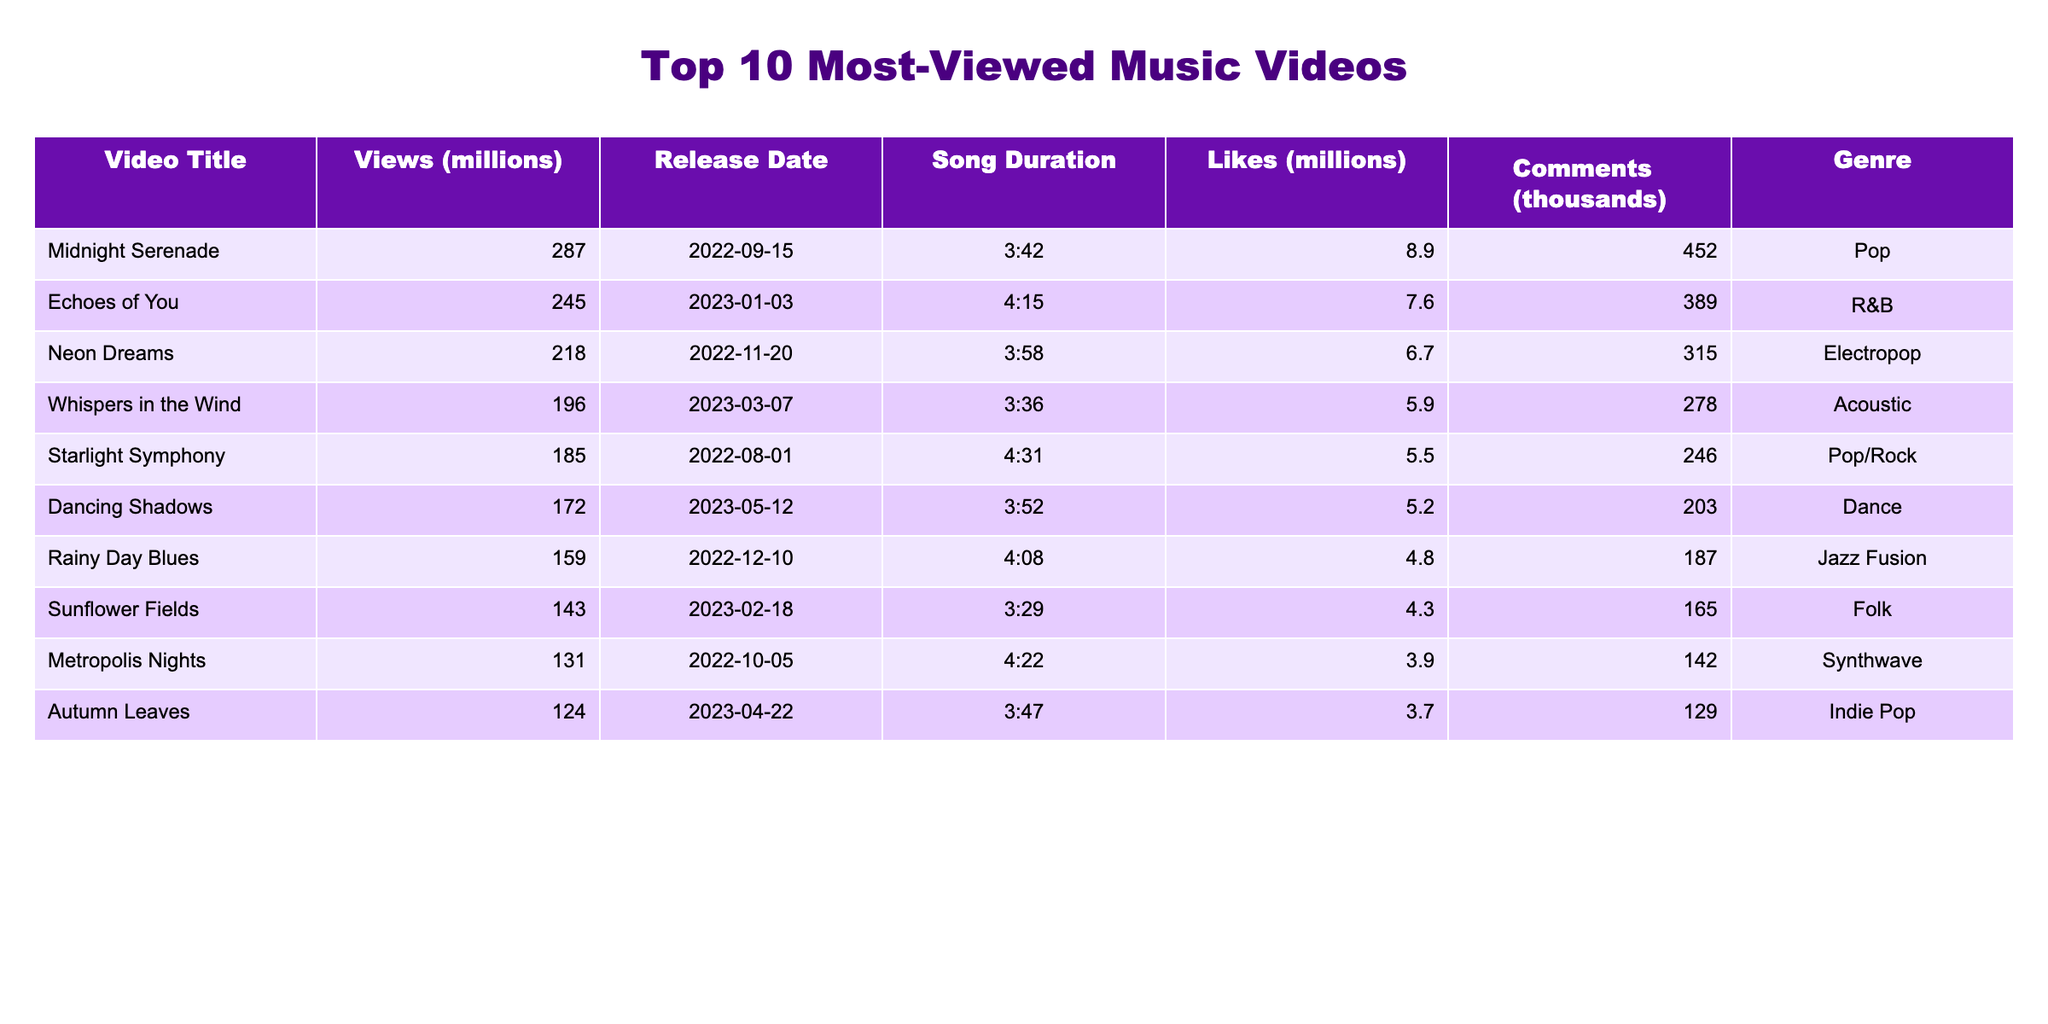What is the title of the most-viewed music video? The table indicates that "Midnight Serenade" has the highest number of views at 287 million.
Answer: Midnight Serenade How many likes did "Whispers in the Wind" receive? The table shows that "Whispers in the Wind" received 5.9 million likes.
Answer: 5.9 million What is the release date of "Neon Dreams"? The release date listed for "Neon Dreams" is November 20, 2022.
Answer: November 20, 2022 Which music video has the least number of views? According to the table, "Autumn Leaves" has the least views at 124 million.
Answer: Autumn Leaves What is the total number of views for the top 3 music videos? The views for the top 3 music videos are 287 million, 245 million, and 218 million. The total is 287 + 245 + 218 = 750 million.
Answer: 750 million What genre does "Dancing Shadows" belong to? The table categorizes "Dancing Shadows" under the Dance genre.
Answer: Dance Is "Starlight Symphony" more popular than "Rainy Day Blues" in terms of views? "Starlight Symphony" has 185 million views while "Rainy Day Blues" has 159 million views. Therefore, "Starlight Symphony" is indeed more popular.
Answer: Yes What is the average number of comments for all music videos listed? The total number of comments is 452 + 389 + 315 + 278 + 246 + 203 + 187 + 165 + 142 + 129 = 2,831 thousand. Dividing by 10 gives an average of 283.1 thousand comments.
Answer: 283.1 thousand Which music video has the longest duration, and how long is it? The video "Starlight Symphony" is the longest at 4 minutes and 31 seconds.
Answer: Starlight Symphony, 4:31 Do any of the top 10 music videos have a genre classified as Jazz Fusion? The table lists "Rainy Day Blues" as being in the Jazz Fusion genre, indicating that yes, there is one.
Answer: Yes What is the difference in views between "Midnight Serenade" and "Echoes of You"? "Midnight Serenade" has 287 million views and "Echoes of You" has 245 million. The difference is 287 - 245 = 42 million views.
Answer: 42 million 